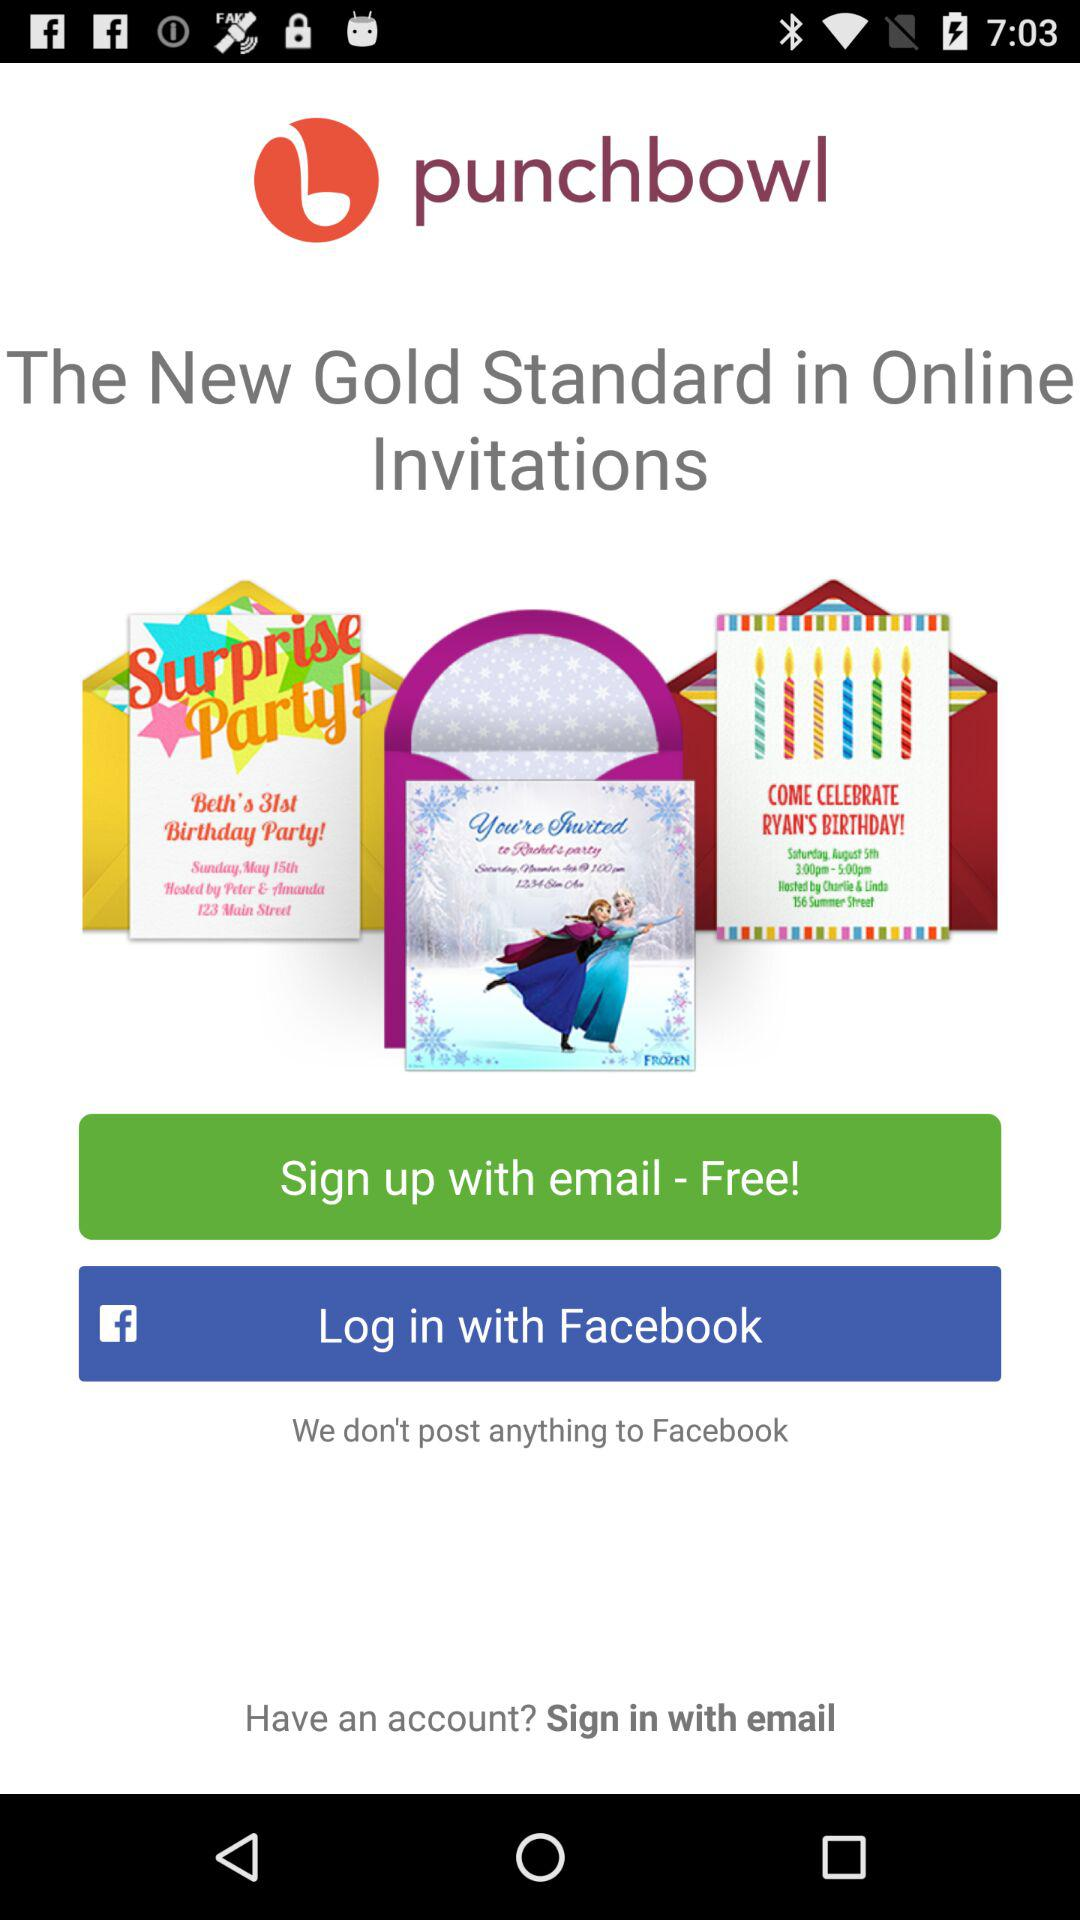What accounts can be used to sign in? To sign in, the "email" account can be used. 